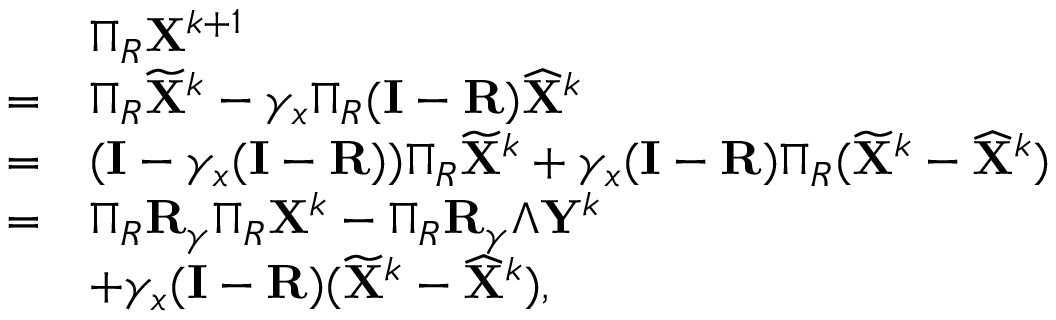Convert formula to latex. <formula><loc_0><loc_0><loc_500><loc_500>\begin{array} { r l } & { \Pi _ { R } { X } ^ { k + 1 } } \\ { = } & { \Pi _ { R } \widetilde { X } ^ { k } - \gamma _ { x } \Pi _ { R } ( { I } - { R } ) \widehat { X } ^ { k } } \\ { = } & { ( { I } - \gamma _ { x } ( { I } - { R } ) ) \Pi _ { R } \widetilde { X } ^ { k } + \gamma _ { x } ( { I } - { R } ) \Pi _ { R } ( \widetilde { X } ^ { k } - \widehat { X } ^ { k } ) } \\ { = } & { \Pi _ { R } { R } _ { \gamma } \Pi _ { R } { X } ^ { k } - \Pi _ { R } { R } _ { \gamma } \Lambda { Y } ^ { k } } \\ & { + \gamma _ { x } ( { I } - { R } ) ( \widetilde { X } ^ { k } - \widehat { X } ^ { k } ) , } \end{array}</formula> 